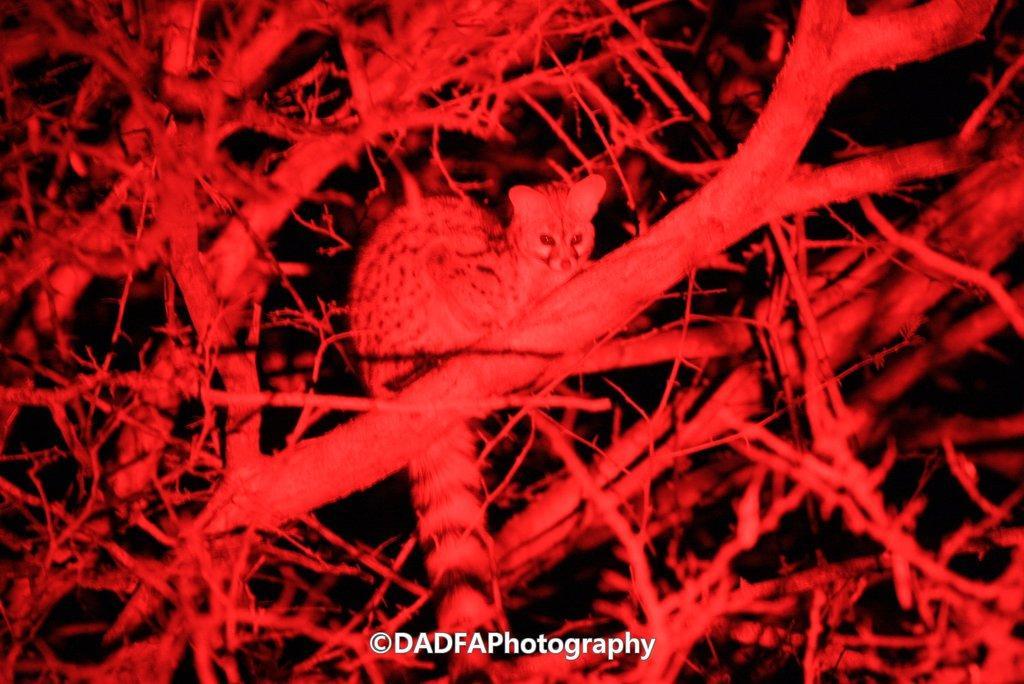Describe this image in one or two sentences. In this image we can see a microscopic picture. 